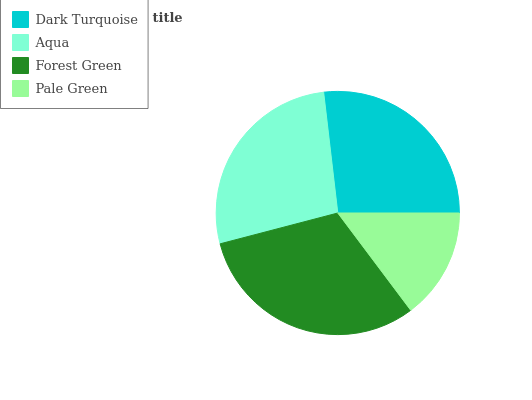Is Pale Green the minimum?
Answer yes or no. Yes. Is Forest Green the maximum?
Answer yes or no. Yes. Is Aqua the minimum?
Answer yes or no. No. Is Aqua the maximum?
Answer yes or no. No. Is Aqua greater than Dark Turquoise?
Answer yes or no. Yes. Is Dark Turquoise less than Aqua?
Answer yes or no. Yes. Is Dark Turquoise greater than Aqua?
Answer yes or no. No. Is Aqua less than Dark Turquoise?
Answer yes or no. No. Is Aqua the high median?
Answer yes or no. Yes. Is Dark Turquoise the low median?
Answer yes or no. Yes. Is Forest Green the high median?
Answer yes or no. No. Is Forest Green the low median?
Answer yes or no. No. 